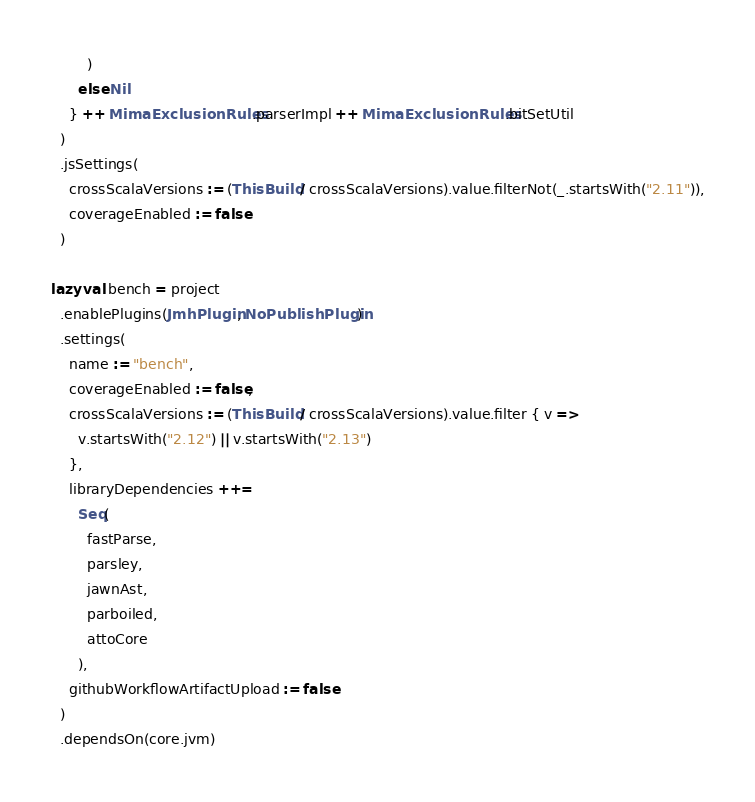Convert code to text. <code><loc_0><loc_0><loc_500><loc_500><_Scala_>        )
      else Nil
    } ++ MimaExclusionRules.parserImpl ++ MimaExclusionRules.bitSetUtil
  )
  .jsSettings(
    crossScalaVersions := (ThisBuild / crossScalaVersions).value.filterNot(_.startsWith("2.11")),
    coverageEnabled := false
  )

lazy val bench = project
  .enablePlugins(JmhPlugin, NoPublishPlugin)
  .settings(
    name := "bench",
    coverageEnabled := false,
    crossScalaVersions := (ThisBuild / crossScalaVersions).value.filter { v =>
      v.startsWith("2.12") || v.startsWith("2.13")
    },
    libraryDependencies ++=
      Seq(
        fastParse,
        parsley,
        jawnAst,
        parboiled,
        attoCore
      ),
    githubWorkflowArtifactUpload := false
  )
  .dependsOn(core.jvm)
</code> 